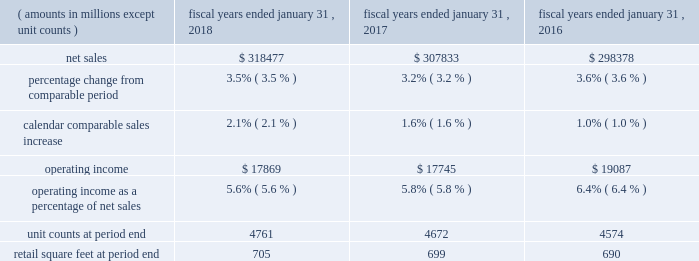Continued investments in ecommerce and technology .
The increase in operating expenses as a percentage of net sales for fiscal 2017 was partially offset by the impact of store closures in the fourth quarter of fiscal 2016 .
Membership and other income was relatively flat for fiscal 2018 and increased $ 1.0 billion a0for fiscal 2017 , when compared to the same period in the previous fiscal year .
While fiscal 2018 included a $ 387 million gain from the sale of suburbia , a $ 47 million gain from a land sale , higher recycling income from our sustainability efforts and higher membership income from increased plus member penetration at sam's club , these gains were less than gains recognized in fiscal 2017 .
Fiscal 2017 included a $ 535 million gain from the sale of our yihaodian business and a $ 194 million gain from the sale of shopping malls in chile .
For fiscal 2018 , loss on extinguishment of debt was a0$ 3.1 billion , due to the early extinguishment of long-term debt which allowed us to retire higher rate debt to reduce interest expense in future periods .
Our effective income tax rate was 30.4% ( 30.4 % ) for fiscal 2018 and 30.3% ( 30.3 % ) for both fiscal 2017 and 2016 .
Although relatively consistent year-over-year , our effective income tax rate may fluctuate from period to period as a result of factors including changes in our assessment of certain tax contingencies , valuation allowances , changes in tax laws , outcomes of administrative audits , the impact of discrete items and the mix of earnings among our u.s .
Operations and international operations .
The reconciliation from the u.s .
Statutory rate to the effective income tax rates for fiscal 2018 , 2017 and 2016 is presented in note 9 in the "notes to consolidated financial statements" and describes the impact of the enactment of the tax cuts and jobs act of 2017 ( the "tax act" ) to the fiscal 2018 effective income tax rate .
As a result of the factors discussed above , we reported $ 10.5 billion and $ 14.3 billion of consolidated net income for fiscal 2018 and 2017 , respectively , which represents a decrease of $ 3.8 billion and $ 0.8 billion for fiscal 2018 and 2017 , respectively , when compared to the previous fiscal year .
Diluted net income per common share attributable to walmart ( "eps" ) was $ 3.28 and $ 4.38 for fiscal 2018 and 2017 , respectively .
Walmart u.s .
Segment .
Net sales for the walmart u.s .
Segment increased $ 10.6 billion or 3.5% ( 3.5 % ) and $ 9.5 billion or 3.2% ( 3.2 % ) for fiscal 2018 and 2017 , respectively , when compared to the previous fiscal year .
The increases in net sales were primarily due to increases in comparable store sales of 2.1% ( 2.1 % ) and 1.6% ( 1.6 % ) for fiscal 2018 and 2017 , respectively , and year-over-year growth in retail square feet of 0.7% ( 0.7 % ) and 1.4% ( 1.4 % ) for fiscal 2018 and 2017 , respectively .
Additionally , for fiscal 2018 , sales generated from ecommerce acquisitions further contributed to the year-over-year increase .
Gross profit rate decreased 24 basis points for fiscal 2018 and increased 24 basis points for fiscal 2017 , when compared to the previous fiscal year .
For fiscal 2018 , the decrease was primarily due to strategic price investments and the mix impact from ecommerce .
Partially offsetting the negative factors for fiscal 2018 was the positive impact of savings from procuring merchandise .
For fiscal 2017 , the increase in gross profit rate was primarily due to improved margin in food and consumables , including the impact of savings in procuring merchandise and lower transportation expense from lower fuel costs .
Operating expenses as a percentage of segment net sales was relatively flat for fiscal 2018 and increased 101 basis points for fiscal 2017 , when compared to the previous fiscal year .
Fiscal 2018 and fiscal 2017 included charges related to discontinued real estate projects of $ 244 million and $ 249 million , respectively .
For fiscal 2017 , the increase was primarily driven by an increase in wage expense due to the investment in the associate wage structure ; the charge related to discontinued real estate projects ; and investments in digital retail and technology .
The increase in operating expenses as a percentage of segment net sales for fiscal 2017 was partially offset by the impact of store closures in fiscal 2016 .
As a result of the factors discussed above , segment operating income increased $ 124 million for fiscal 2018 and decreased $ 1.3 billion for fiscal 2017 , respectively. .
What is the net income margin for 2018? 
Computations: ((10.5 * 1000) / 318477)
Answer: 0.03297. 